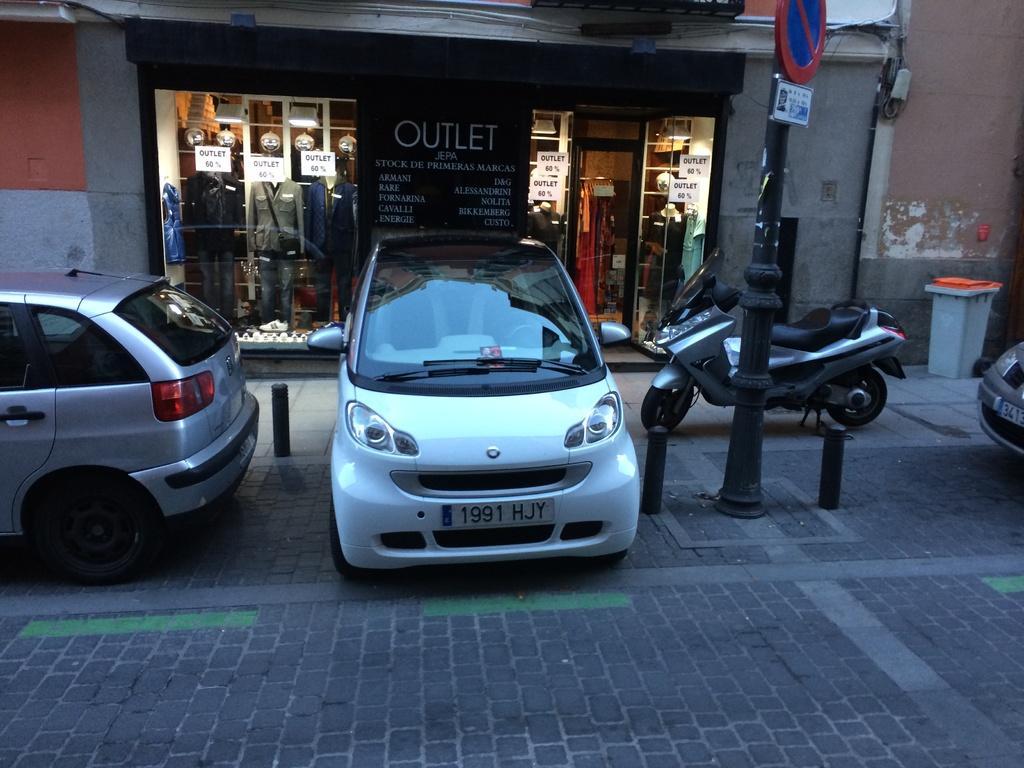Describe this image in one or two sentences. In the middle of the image we can see some vehicles, motorcycles, poles and sign boards. Behind them there is a dustbin and building. In the building we can see some clothes and posters. 